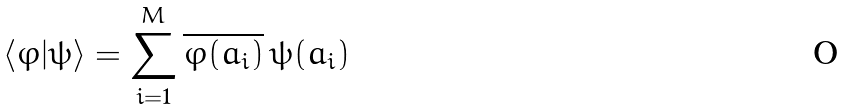<formula> <loc_0><loc_0><loc_500><loc_500>\langle \varphi | \psi \rangle = \sum _ { i = 1 } ^ { M } \overline { \varphi ( a _ { i } ) } \, \psi ( a _ { i } )</formula> 